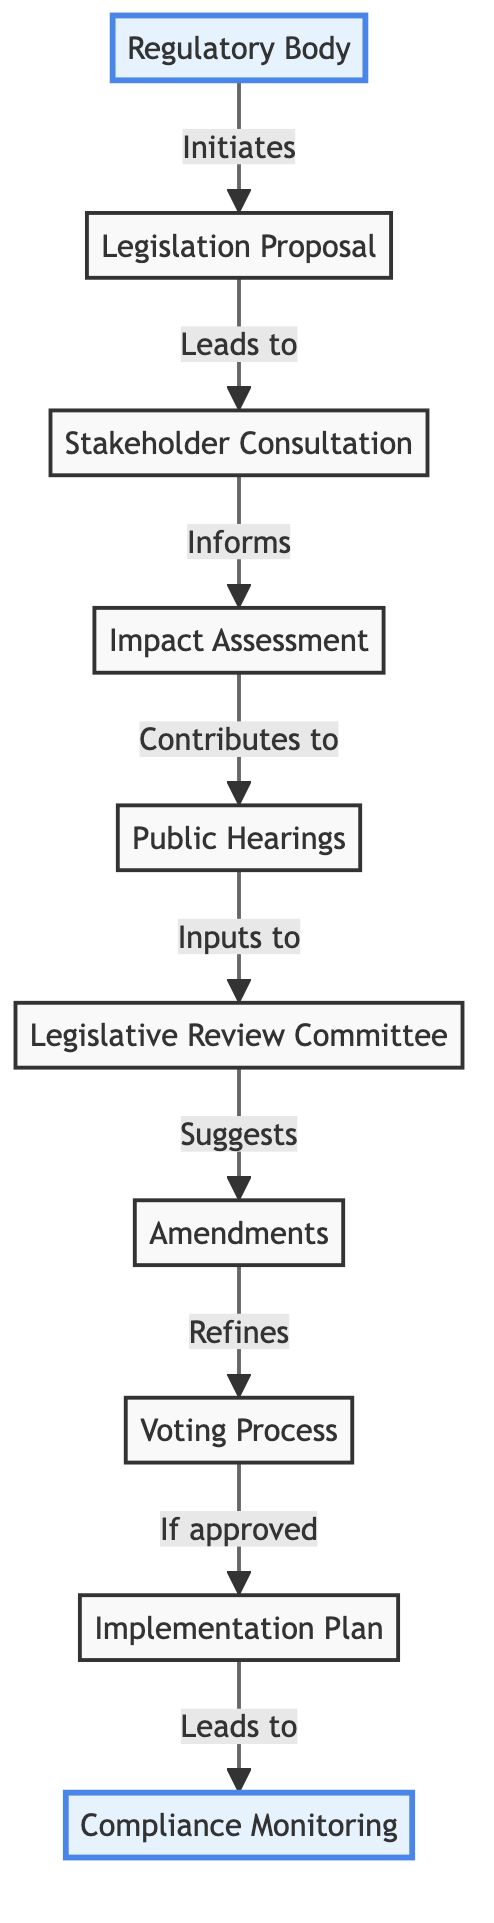What is the first step in the flow of information? The first step in the flow is indicated by the arrow leading from the "Regulatory Body" to "Legislation Proposal". This shows that the regulatory body initiates the process by proposing legislation.
Answer: Regulatory Body What follows the Stakeholder Consultation? The node that follows "Stakeholder Consultation" is "Impact Assessment", which indicates that after consultation, the impacts of the proposed regulations are evaluated.
Answer: Impact Assessment How many nodes are present in this flow chart? By counting all the unique elements shown in the diagram, there are ten nodes (Regulatory Body, Legislation Proposal, Stakeholder Consultation, Impact Assessment, Public Hearings, Legislative Review Committee, Amendments, Voting Process, Implementation Plan, Compliance Monitoring).
Answer: Ten What does the Legislative Review Committee suggest? The flow from "Legislative Review Committee" points to "Amendments", which indicates that the committee makes suggestions on changes to the original proposal.
Answer: Amendments What happens after the Voting Process if the proposal is approved? If the proposal is approved during the "Voting Process", the flow leads to the "Implementation Plan", indicating that the next step is to outline how the new regulations will be enforced.
Answer: Implementation Plan What connects the Public Hearings to the Legislative Review Committee? The connection between "Public Hearings" and "Legislative Review Committee" is indicated by an arrow labeled “Inputs to”, showing that the public comments received during hearings inform the committee's analysis and discussions.
Answer: Inputs to Which element indicates ongoing supervision after implementation? The last node in the flow, "Compliance Monitoring", highlights that this is the stage where oversight occurs to ensure adherence to the new regulations post-implementation.
Answer: Compliance Monitoring How is the Impact Assessment related to Stakeholder Consultation? The arrow from "Stakeholder Consultation" to "Impact Assessment", labeled “Informs”, illustrates that the input and feedback gathered during consultation guide the assessment of the potential effects of the proposed regulations.
Answer: Informs 